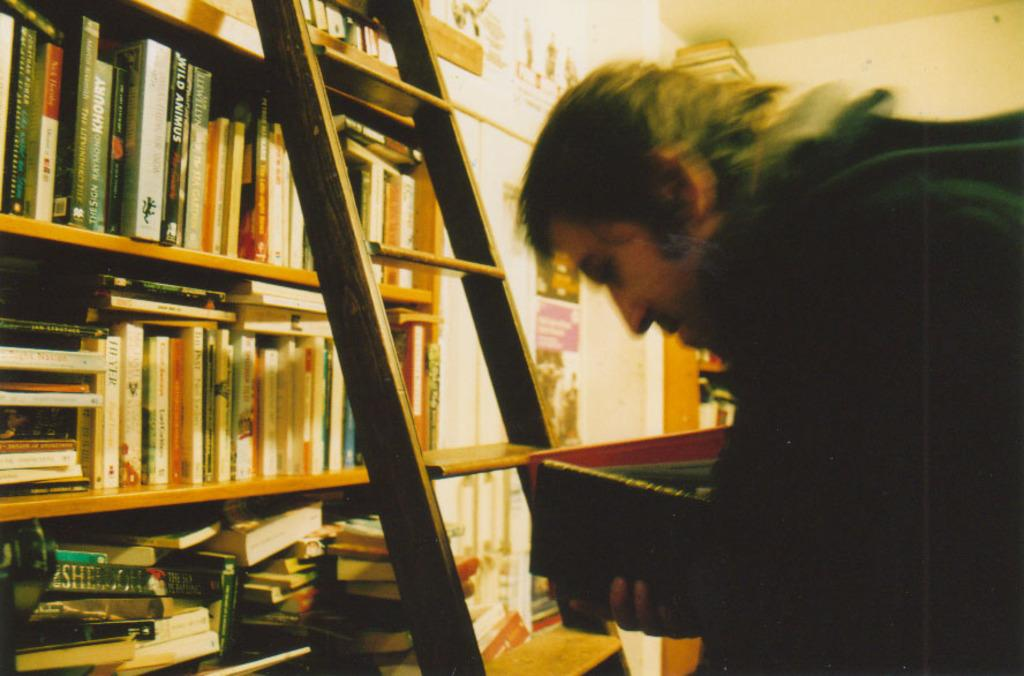Who or what is present in the image? There is a person in the image. What is the person holding? The person is holding a book. What object is in front of the person? There is a ladder in front of the person. What can be seen on the shelves in the image? There are shelves with books in the image. What decorations are on the wall? A: There are posters on the wall in the image. What type of suit is the person wearing in the image? There is no suit visible in the image; the person is not wearing any clothing mentioned in the provided facts. 